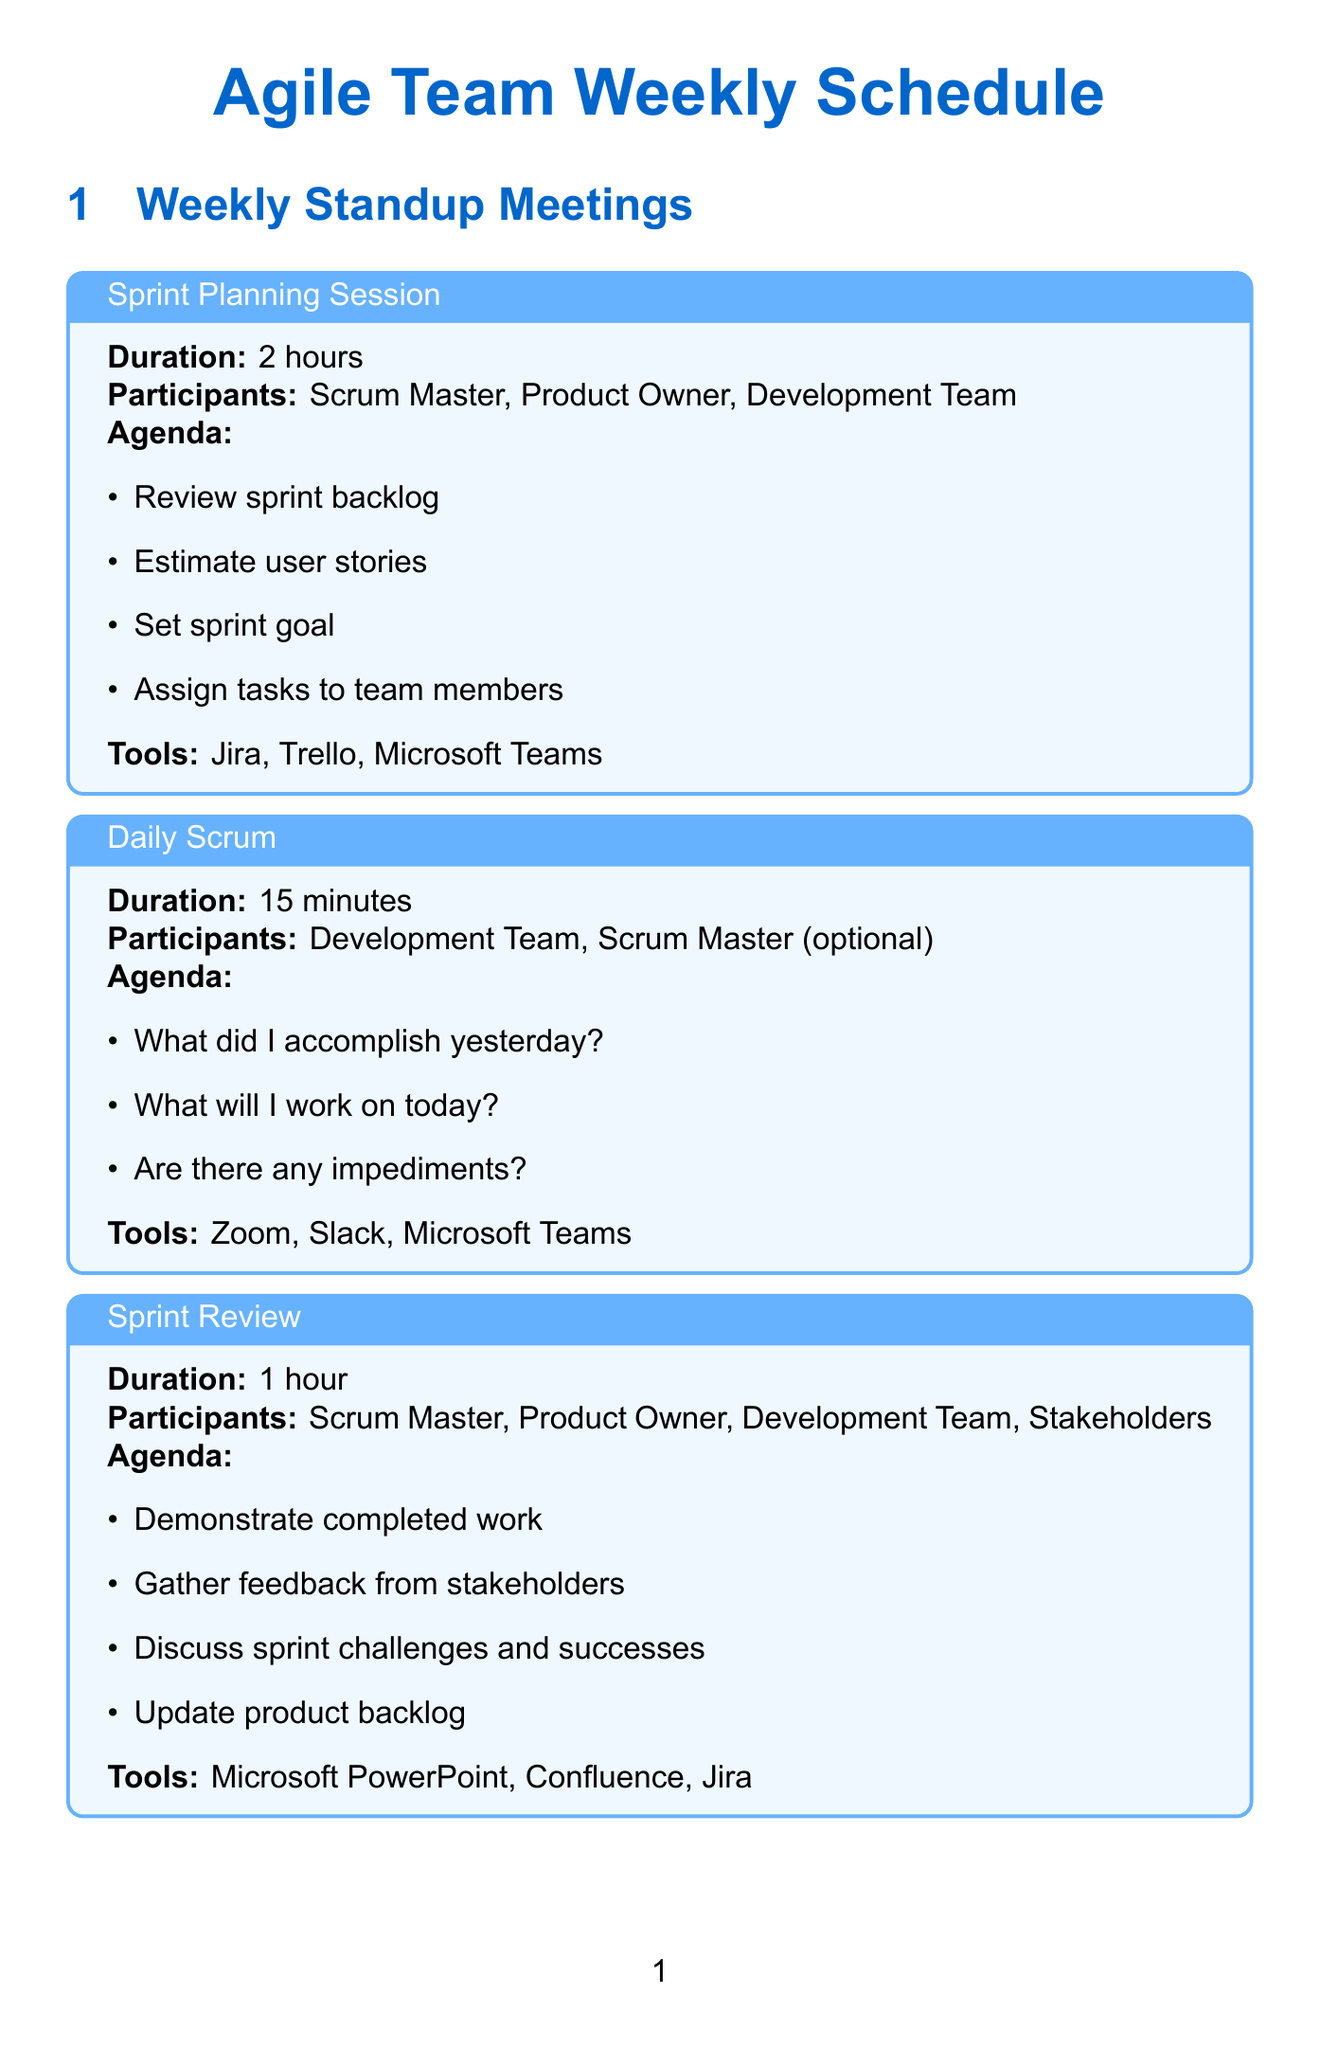What is the duration of the Sprint Planning Session? The duration is mentioned in the document under the Sprint Planning Session item, which is 2 hours.
Answer: 2 hours Who are the participants in the Daily Scrum? The participants listed in the Daily Scrum section include the Development Team and the Scrum Master (optional).
Answer: Development Team, Scrum Master (optional) What is one of the agenda items for the Sprint Review? The document specifies several agenda items for the Sprint Review; one of them is to demonstrate completed work.
Answer: Demonstrate completed work What tools are used for Backlog Refinement? The tools listed for Backlog Refinement are Jira, Azure DevOps, and Confluence.
Answer: Jira, Azure DevOps, Confluence How long is the Agile Metrics Review scheduled for? The document states that the duration for the Agile Metrics Review is 1 hour.
Answer: 1 hour Which meeting involves Technology Analysts from different teams? The meeting that includes Technology Analysts from different teams is the Cross-team Coordination Meeting, as listed in the document.
Answer: Cross-team Coordination Meeting What is the purpose of the Agile Transformation Progress Review? The Agile Transformation Progress Review aims to analyze the impact on company performance according to the agenda items listed.
Answer: Analyze impact on company performance Name one tool used in the Sprint Retrospective. The Sprint Retrospective mentions Miro, Retrium, and FunRetro as tools; one tool is Miro.
Answer: Miro 